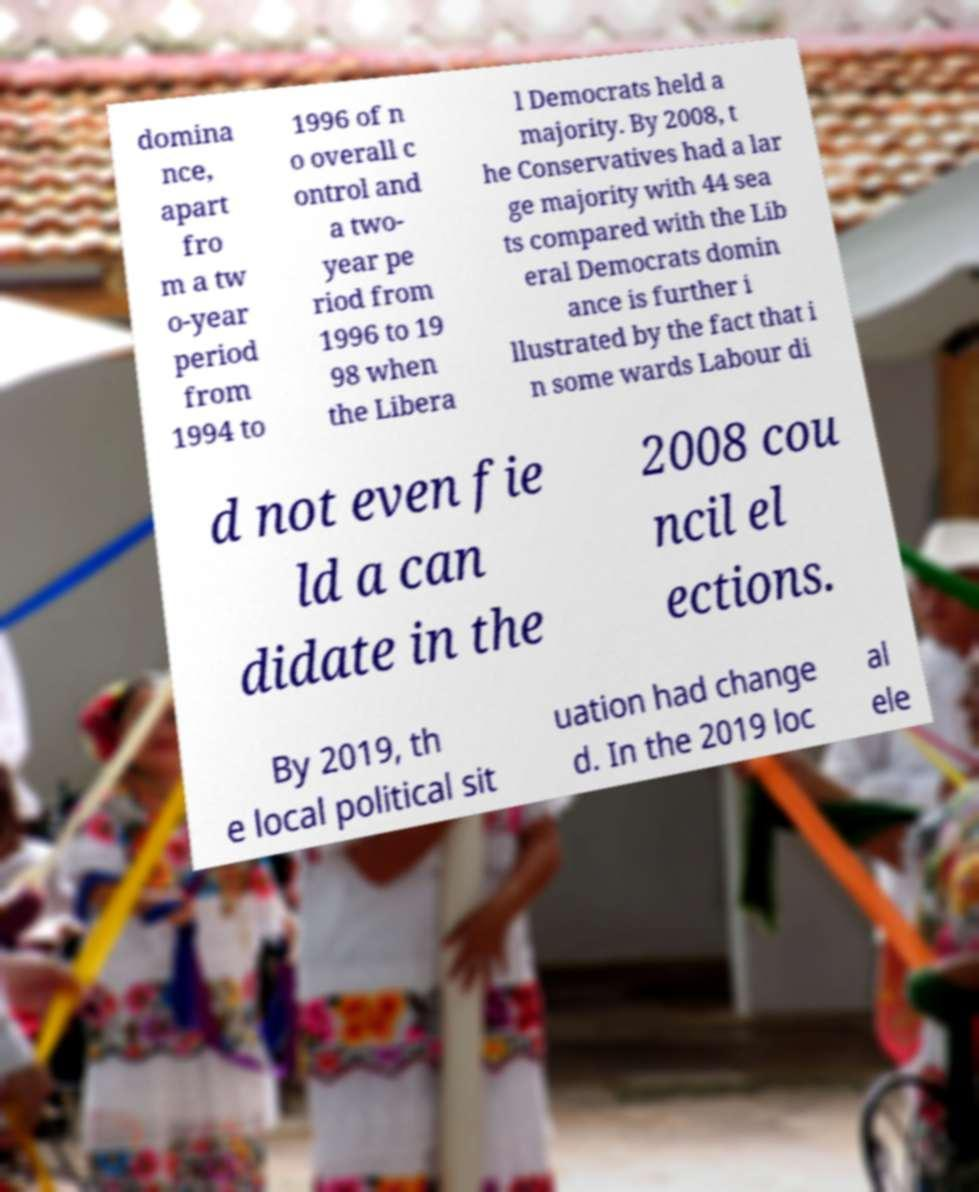I need the written content from this picture converted into text. Can you do that? domina nce, apart fro m a tw o-year period from 1994 to 1996 of n o overall c ontrol and a two- year pe riod from 1996 to 19 98 when the Libera l Democrats held a majority. By 2008, t he Conservatives had a lar ge majority with 44 sea ts compared with the Lib eral Democrats domin ance is further i llustrated by the fact that i n some wards Labour di d not even fie ld a can didate in the 2008 cou ncil el ections. By 2019, th e local political sit uation had change d. In the 2019 loc al ele 